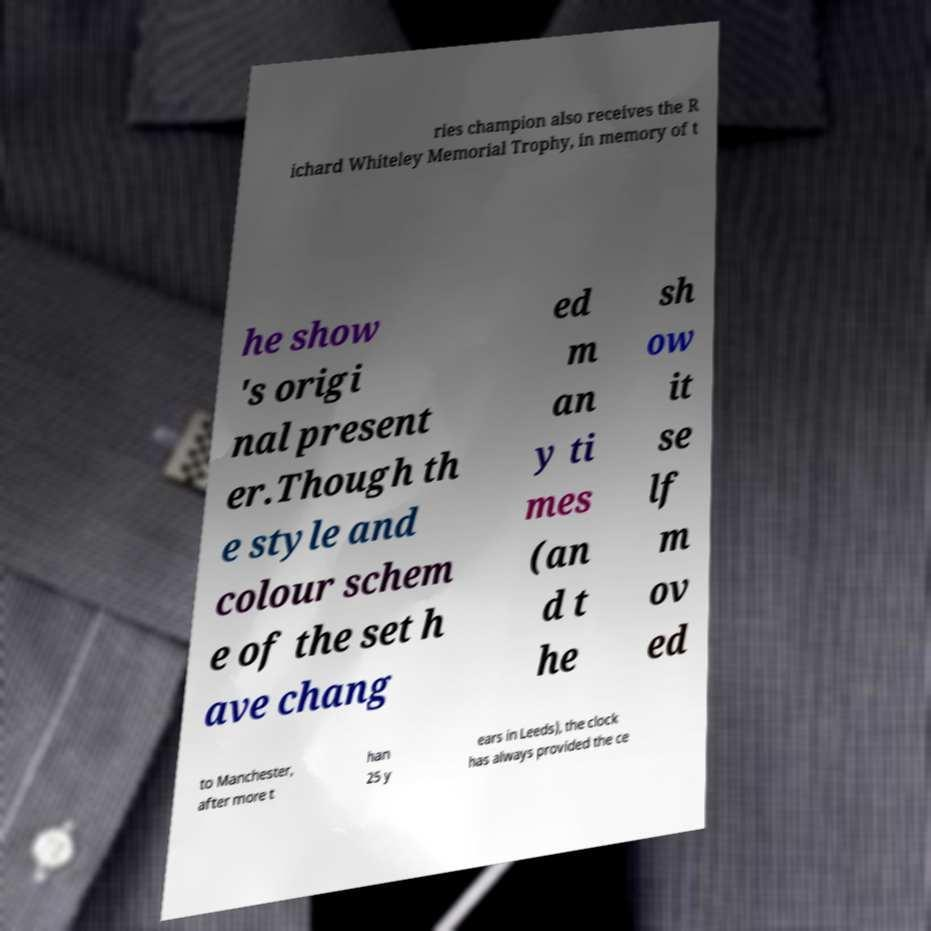I need the written content from this picture converted into text. Can you do that? ries champion also receives the R ichard Whiteley Memorial Trophy, in memory of t he show 's origi nal present er.Though th e style and colour schem e of the set h ave chang ed m an y ti mes (an d t he sh ow it se lf m ov ed to Manchester, after more t han 25 y ears in Leeds), the clock has always provided the ce 